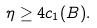Convert formula to latex. <formula><loc_0><loc_0><loc_500><loc_500>\eta \geq 4 c _ { 1 } ( B ) .</formula> 